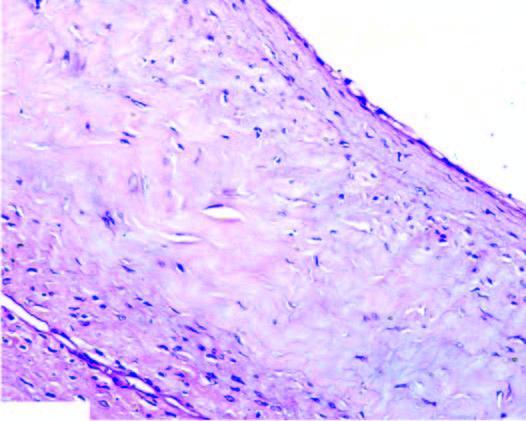what does the cyst wall show?
Answer the question using a single word or phrase. Myxoid degeneration 